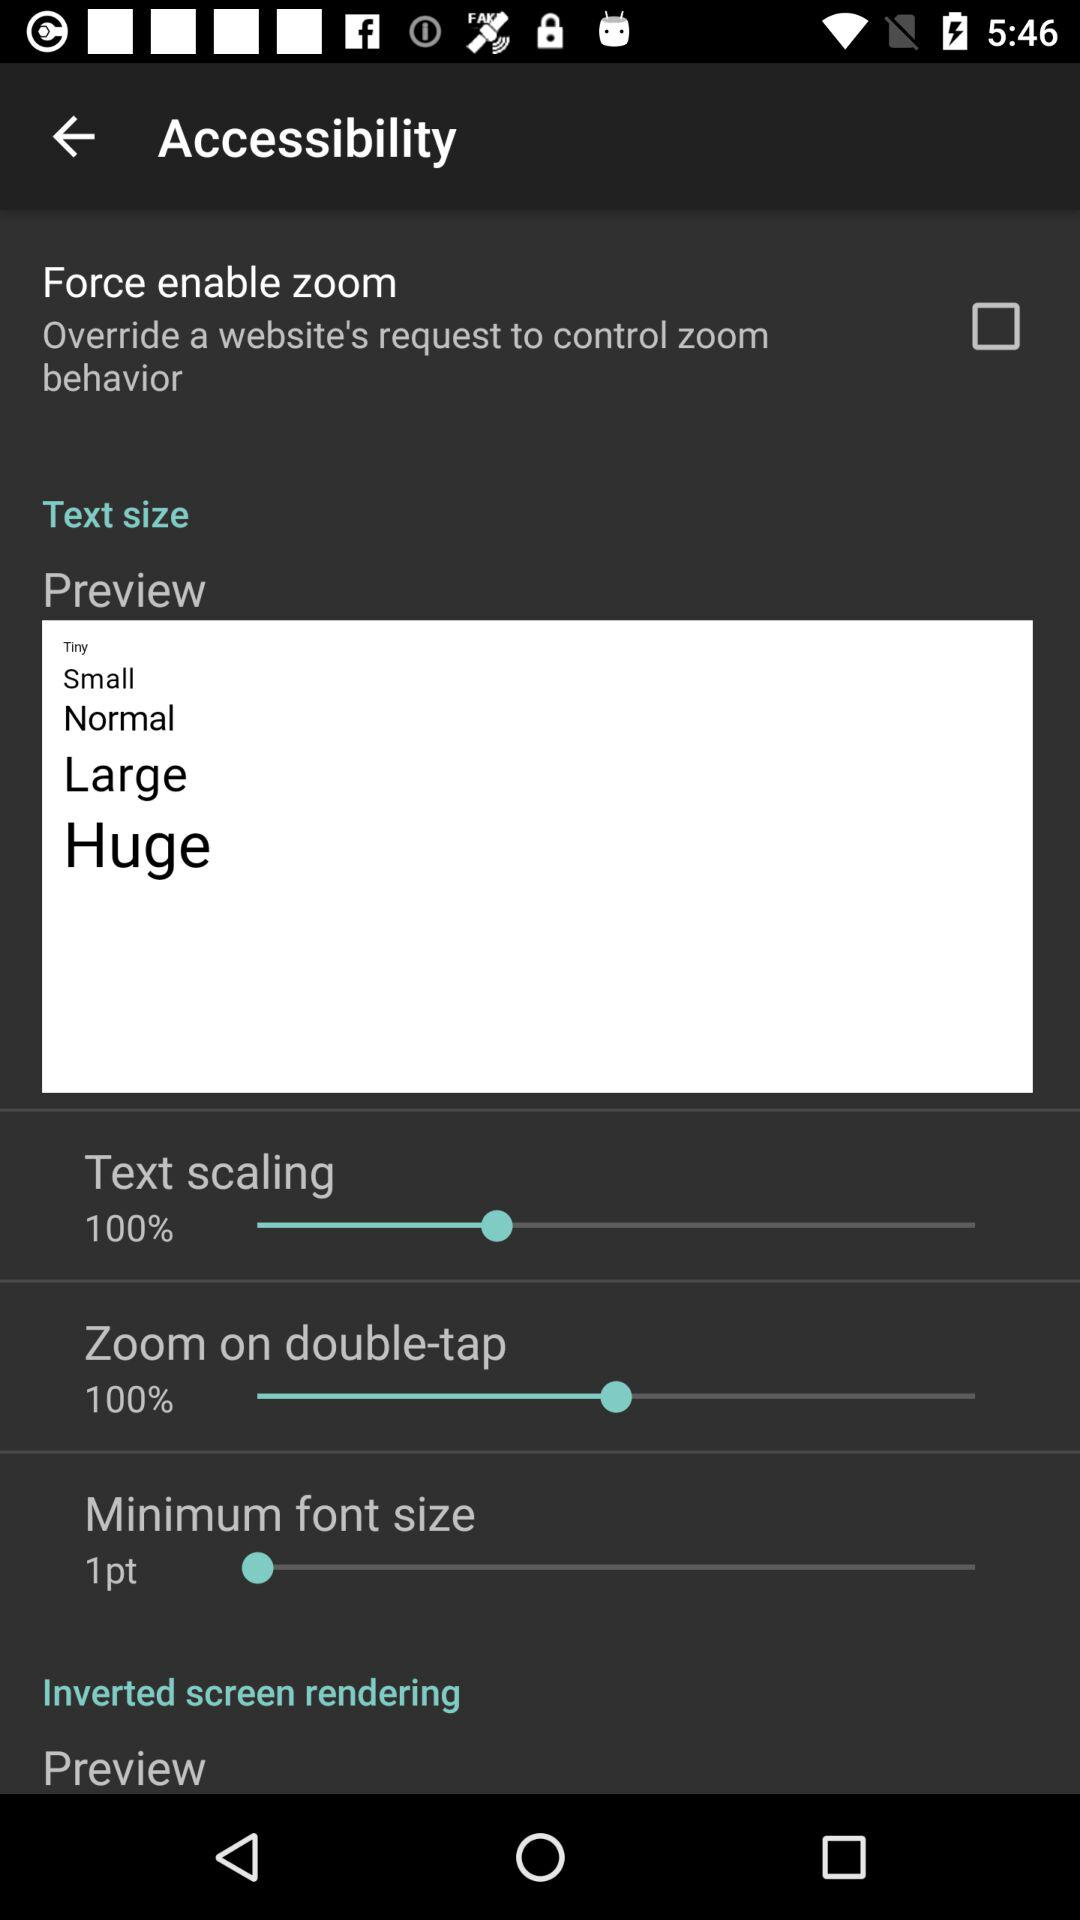What is the text scaling percentage? The text scaling percentage is 100%. 